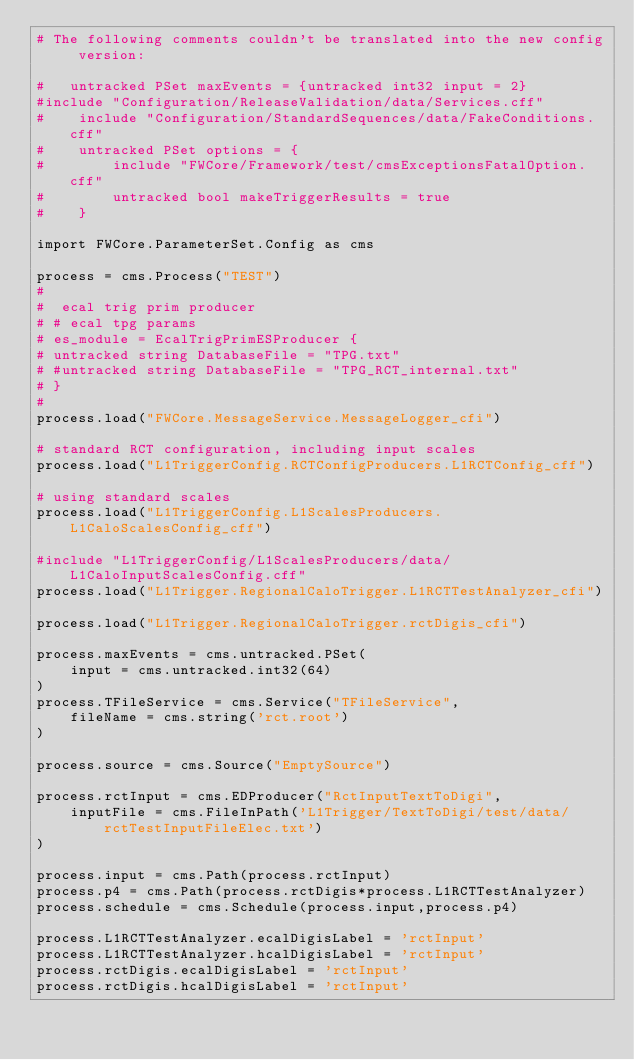Convert code to text. <code><loc_0><loc_0><loc_500><loc_500><_Python_># The following comments couldn't be translated into the new config version:

#	untracked PSet maxEvents = {untracked int32 input = 2}
#include "Configuration/ReleaseValidation/data/Services.cff"
#    include "Configuration/StandardSequences/data/FakeConditions.cff"
#    untracked PSet options = {
#        include "FWCore/Framework/test/cmsExceptionsFatalOption.cff"
#        untracked bool makeTriggerResults = true
#    }

import FWCore.ParameterSet.Config as cms

process = cms.Process("TEST")
# 
#  ecal trig prim producer 
# # ecal tpg params
# es_module = EcalTrigPrimESProducer {
# untracked string DatabaseFile = "TPG.txt"
# #untracked string DatabaseFile = "TPG_RCT_internal.txt"
# }
# 
process.load("FWCore.MessageService.MessageLogger_cfi")

# standard RCT configuration, including input scales
process.load("L1TriggerConfig.RCTConfigProducers.L1RCTConfig_cff")

# using standard scales
process.load("L1TriggerConfig.L1ScalesProducers.L1CaloScalesConfig_cff")

#include "L1TriggerConfig/L1ScalesProducers/data/L1CaloInputScalesConfig.cff"
process.load("L1Trigger.RegionalCaloTrigger.L1RCTTestAnalyzer_cfi")

process.load("L1Trigger.RegionalCaloTrigger.rctDigis_cfi")

process.maxEvents = cms.untracked.PSet(
    input = cms.untracked.int32(64)
)
process.TFileService = cms.Service("TFileService",
    fileName = cms.string('rct.root')
)

process.source = cms.Source("EmptySource")

process.rctInput = cms.EDProducer("RctInputTextToDigi",
    inputFile = cms.FileInPath('L1Trigger/TextToDigi/test/data/rctTestInputFileElec.txt')
)

process.input = cms.Path(process.rctInput)
process.p4 = cms.Path(process.rctDigis*process.L1RCTTestAnalyzer)
process.schedule = cms.Schedule(process.input,process.p4)

process.L1RCTTestAnalyzer.ecalDigisLabel = 'rctInput'
process.L1RCTTestAnalyzer.hcalDigisLabel = 'rctInput'
process.rctDigis.ecalDigisLabel = 'rctInput'
process.rctDigis.hcalDigisLabel = 'rctInput'


</code> 